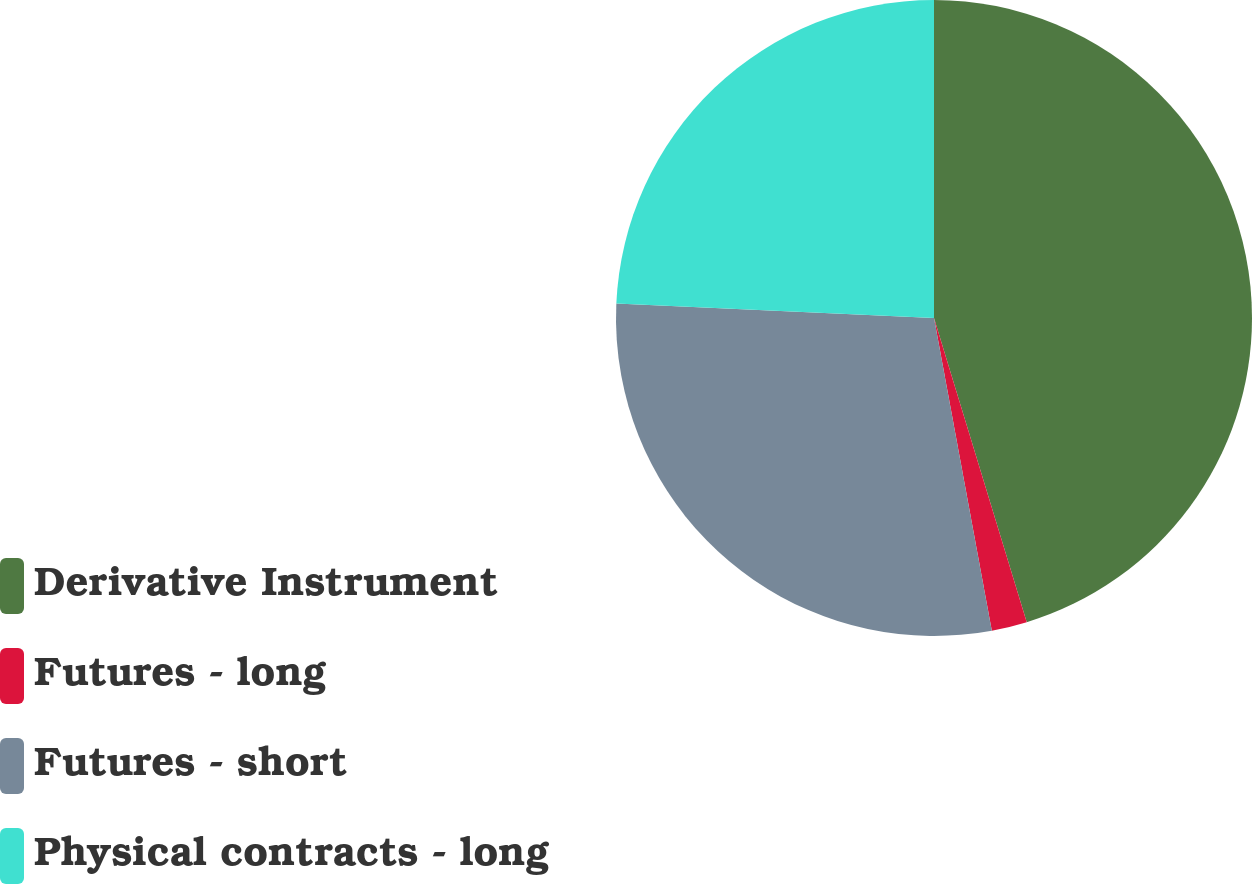Convert chart. <chart><loc_0><loc_0><loc_500><loc_500><pie_chart><fcel>Derivative Instrument<fcel>Futures - long<fcel>Futures - short<fcel>Physical contracts - long<nl><fcel>45.29%<fcel>1.8%<fcel>28.63%<fcel>24.28%<nl></chart> 